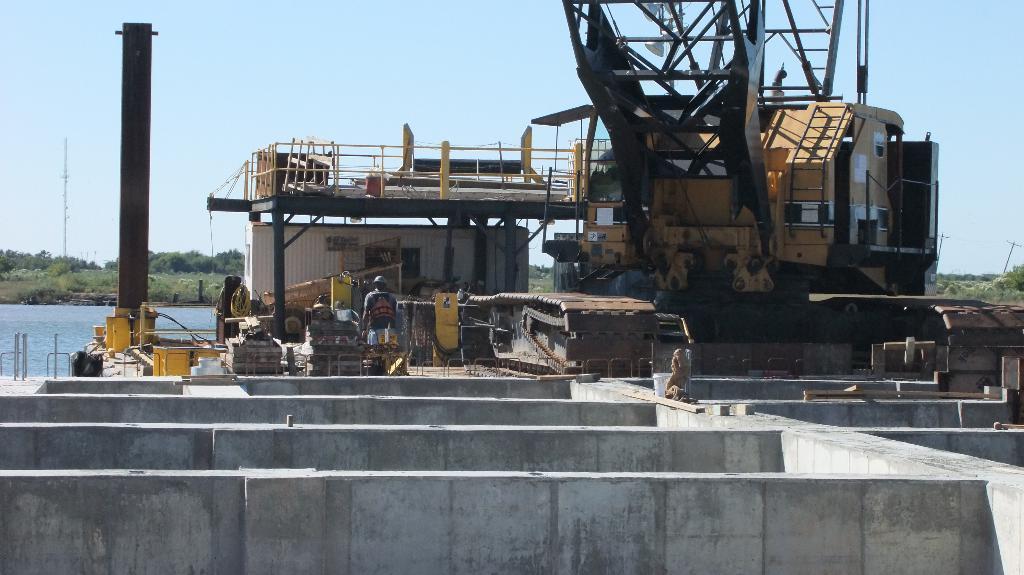How would you summarize this image in a sentence or two? In this image I can see wall, dividers, vehicle, shed, metal rods, machine and a person is standing on the road. In the background I can see trees, water, towers, light poles, fence and the sky. This image is taken may be during a day. 